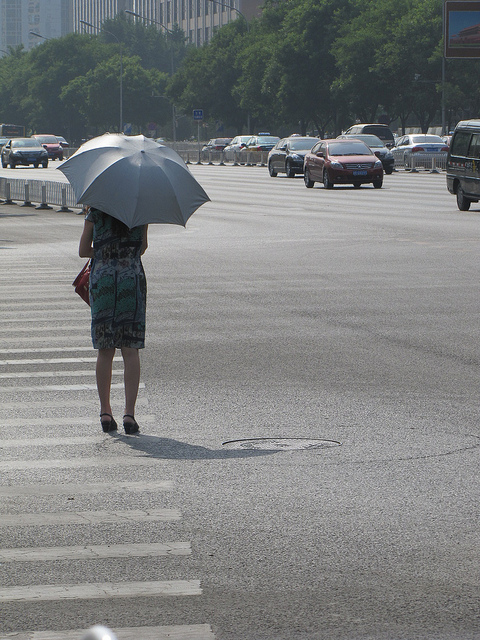<image>How many parking spaces are there? I don't know how many parking spaces are there. It can be multiple, many or hundreds. How many parking spaces are there? There is no sure answer to how many parking spaces there are. It can be zero or many. 